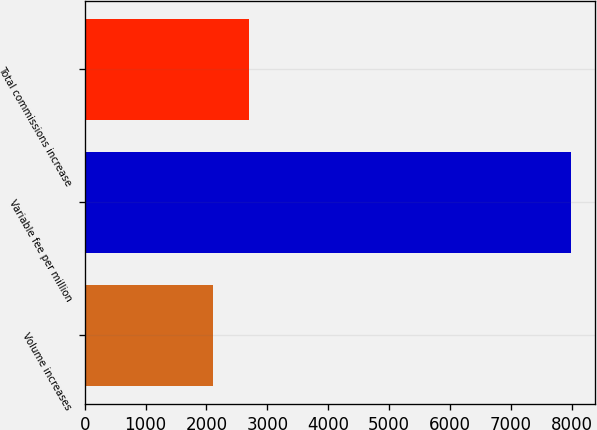<chart> <loc_0><loc_0><loc_500><loc_500><bar_chart><fcel>Volume increases<fcel>Variable fee per million<fcel>Total commissions increase<nl><fcel>2106<fcel>7987<fcel>2694.1<nl></chart> 